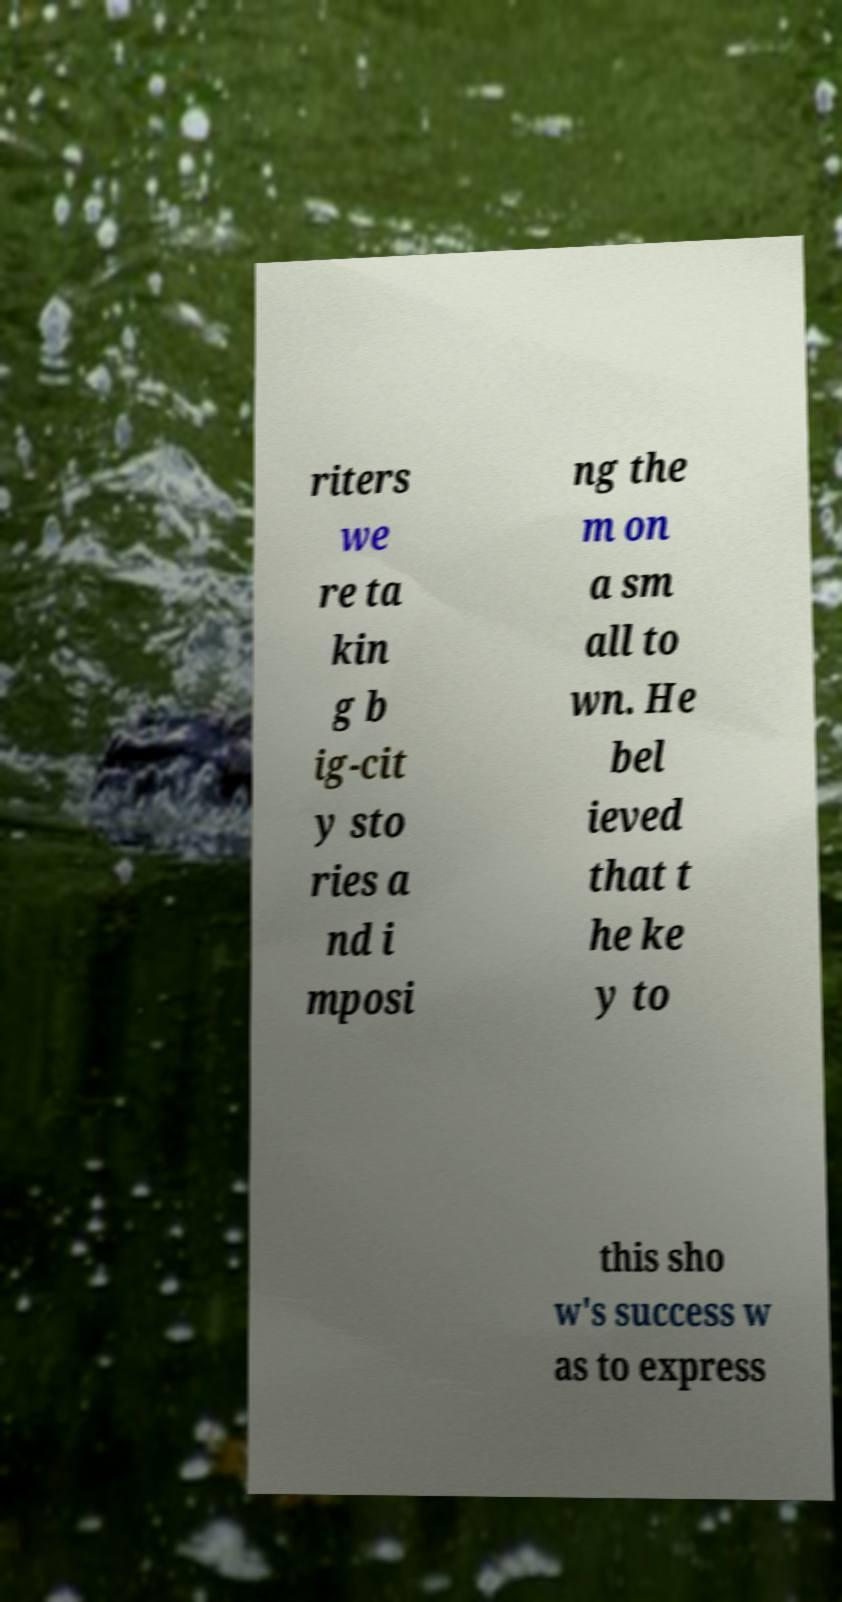Can you accurately transcribe the text from the provided image for me? riters we re ta kin g b ig-cit y sto ries a nd i mposi ng the m on a sm all to wn. He bel ieved that t he ke y to this sho w's success w as to express 